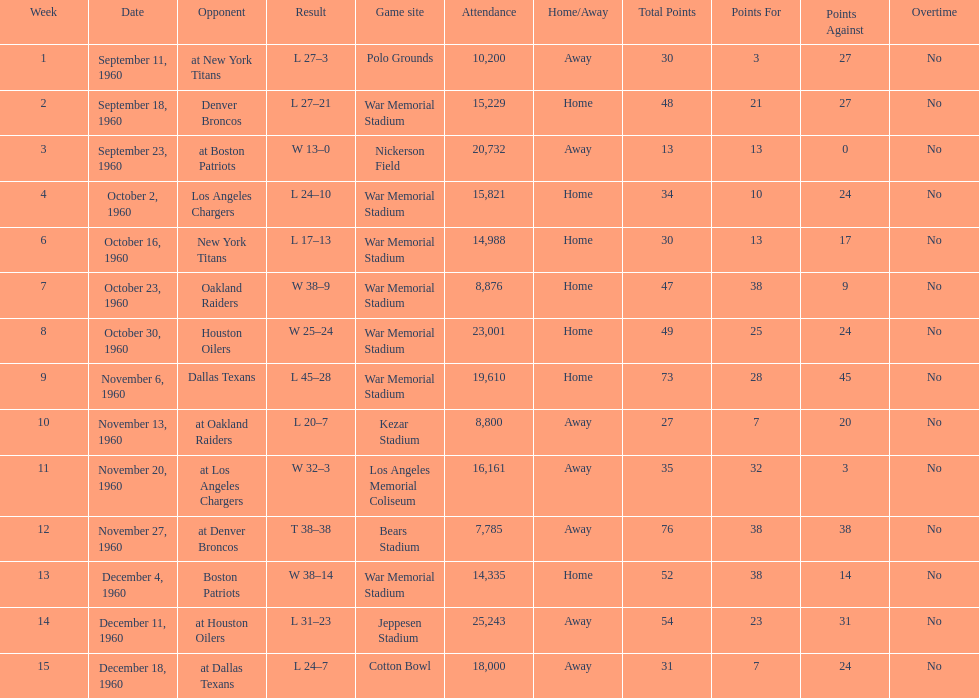How many games had an attendance of 10,000 at most? 11. 